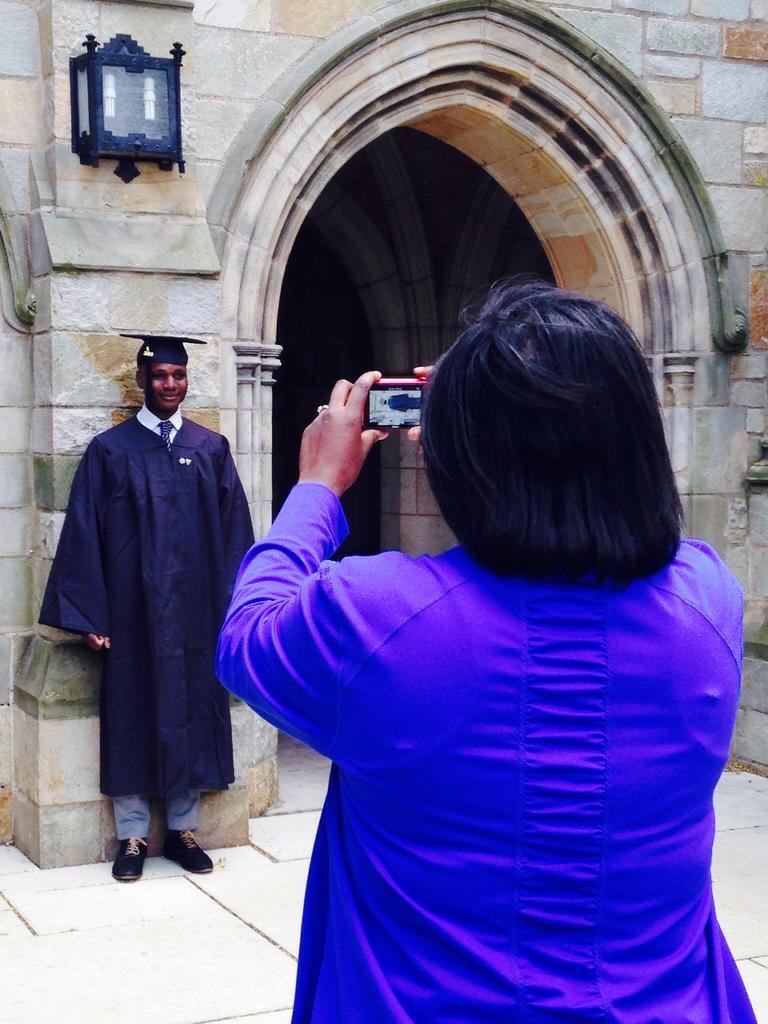Can you describe this image briefly? In this image we can see two persons, a lady taking a picture with a camera, behind them there is a light, and the wall. 